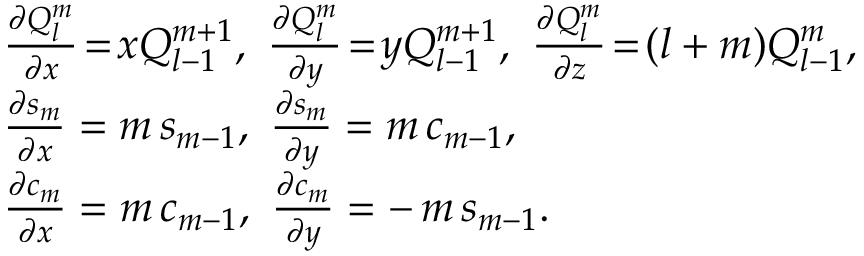<formula> <loc_0><loc_0><loc_500><loc_500>\begin{array} { r l } & { \frac { \partial Q _ { l } ^ { m } } { \partial x } \, = \, x Q _ { l - 1 } ^ { m + 1 } , \ \frac { \partial Q _ { l } ^ { m } } { \partial y } \, = \, y Q _ { l - 1 } ^ { m + 1 } , \ \frac { \partial Q _ { l } ^ { m } } { \partial z } \, = \, ( l + m ) Q _ { l - 1 } ^ { m } , } \\ & { \frac { \partial s _ { m } } { \partial x } = m \, s _ { m - 1 } , \ \frac { \partial s _ { m } } { \partial y } = m \, c _ { m - 1 } , \ } \\ & { \frac { \partial c _ { m } } { \partial x } = m \, c _ { m - 1 } , \ \frac { \partial c _ { m } } { \partial y } = - \, m \, s _ { m - 1 } . } \end{array}</formula> 